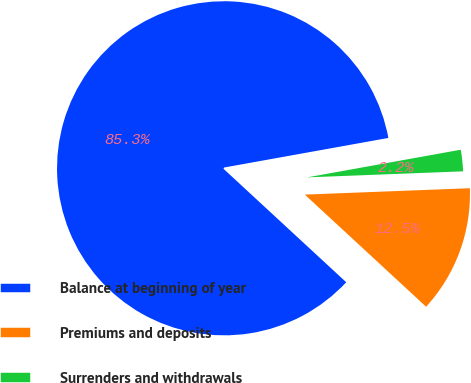Convert chart. <chart><loc_0><loc_0><loc_500><loc_500><pie_chart><fcel>Balance at beginning of year<fcel>Premiums and deposits<fcel>Surrenders and withdrawals<nl><fcel>85.29%<fcel>12.49%<fcel>2.22%<nl></chart> 